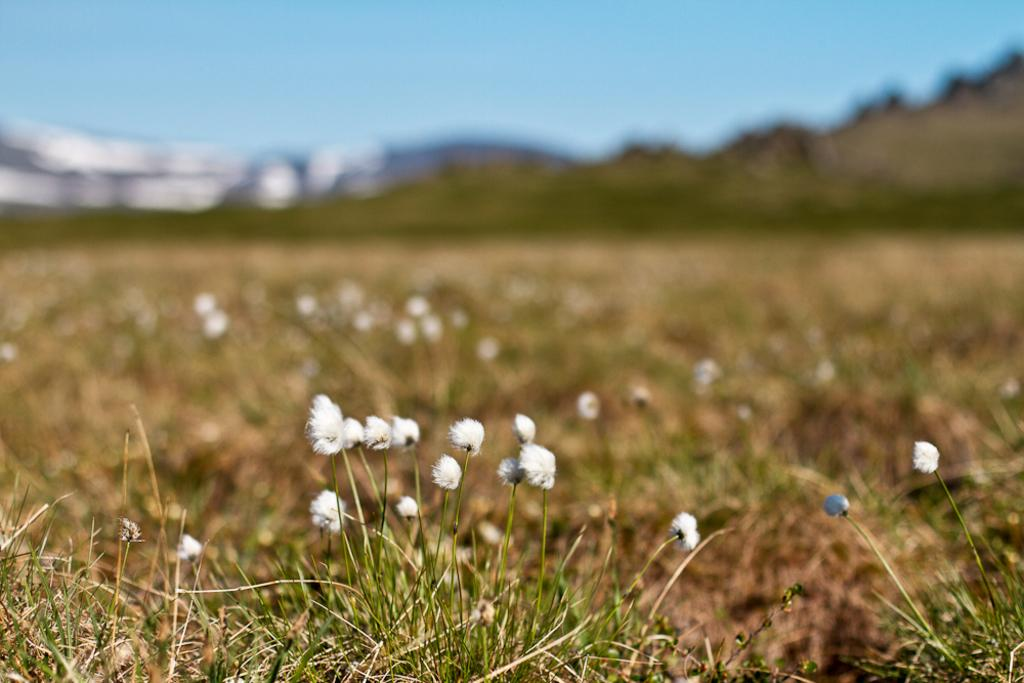What type of vegetation can be seen in the image? There are flowers and plants in the image. What is visible in the background of the image? Mountains and the sky are visible in the background of the image. Can you describe the quality of the image? The image is blurry. What type of wool is being used to create the art in the image? There is no wool or art present in the image; it features flowers, plants, mountains, and the sky. 